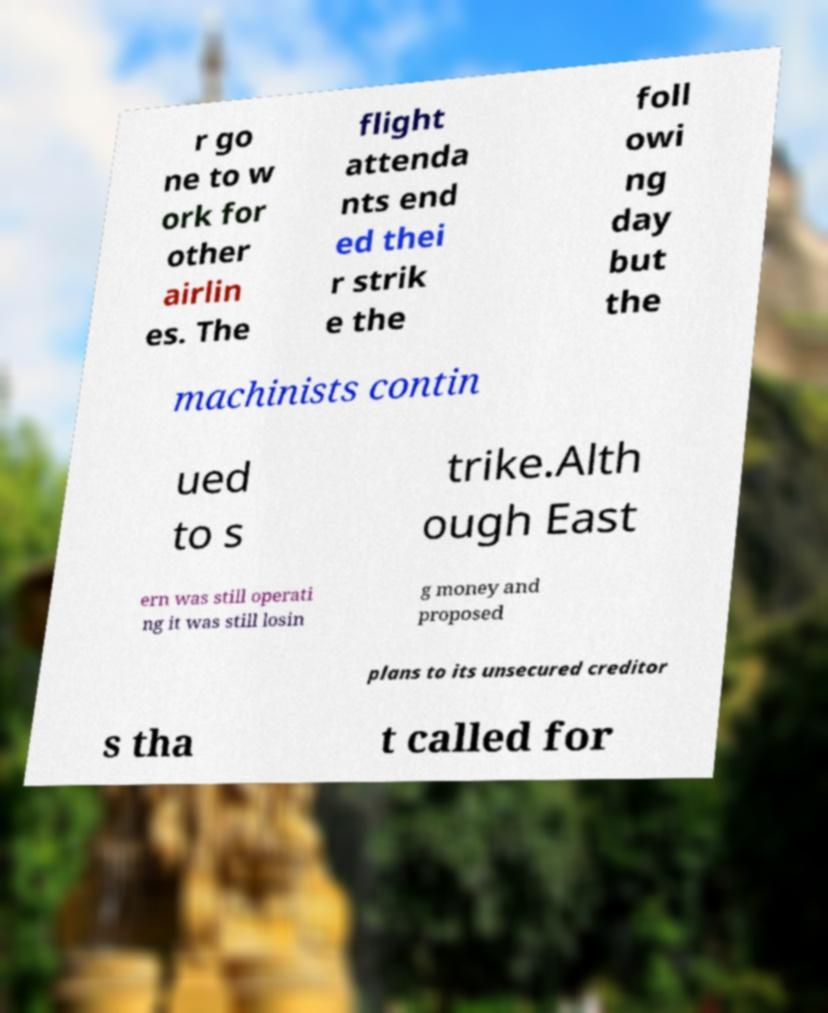What messages or text are displayed in this image? I need them in a readable, typed format. r go ne to w ork for other airlin es. The flight attenda nts end ed thei r strik e the foll owi ng day but the machinists contin ued to s trike.Alth ough East ern was still operati ng it was still losin g money and proposed plans to its unsecured creditor s tha t called for 